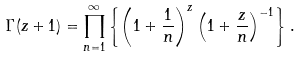Convert formula to latex. <formula><loc_0><loc_0><loc_500><loc_500>\Gamma ( z + 1 ) = \prod _ { n = 1 } ^ { \infty } \left \{ \left ( 1 + \frac { 1 } { n } \right ) ^ { z } \left ( 1 + \frac { z } { n } \right ) ^ { - 1 } \right \} .</formula> 